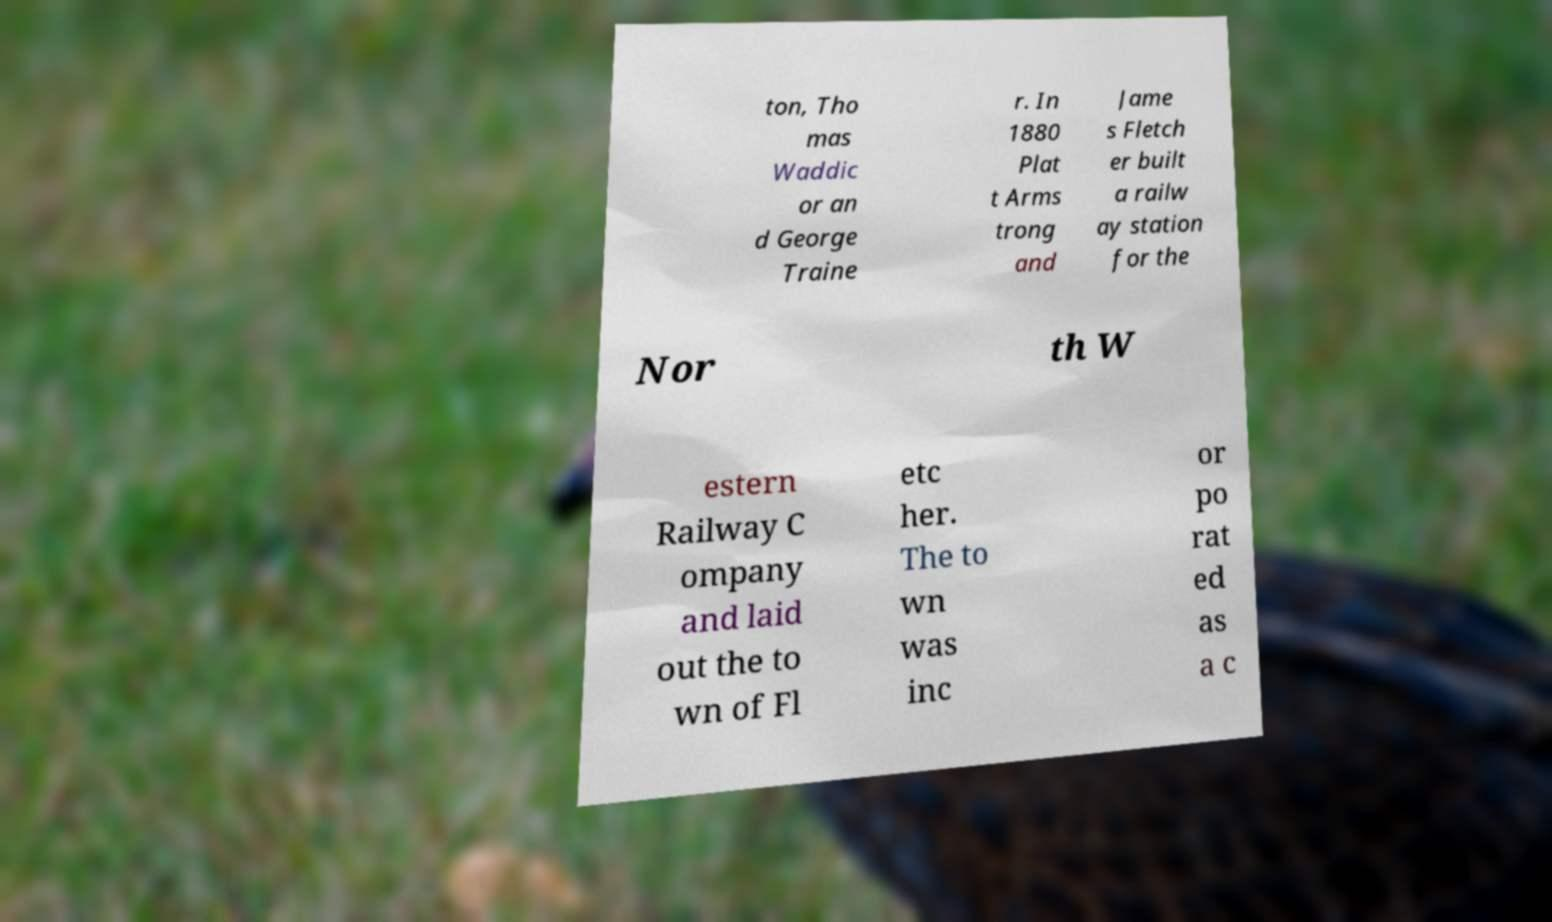Could you extract and type out the text from this image? ton, Tho mas Waddic or an d George Traine r. In 1880 Plat t Arms trong and Jame s Fletch er built a railw ay station for the Nor th W estern Railway C ompany and laid out the to wn of Fl etc her. The to wn was inc or po rat ed as a c 